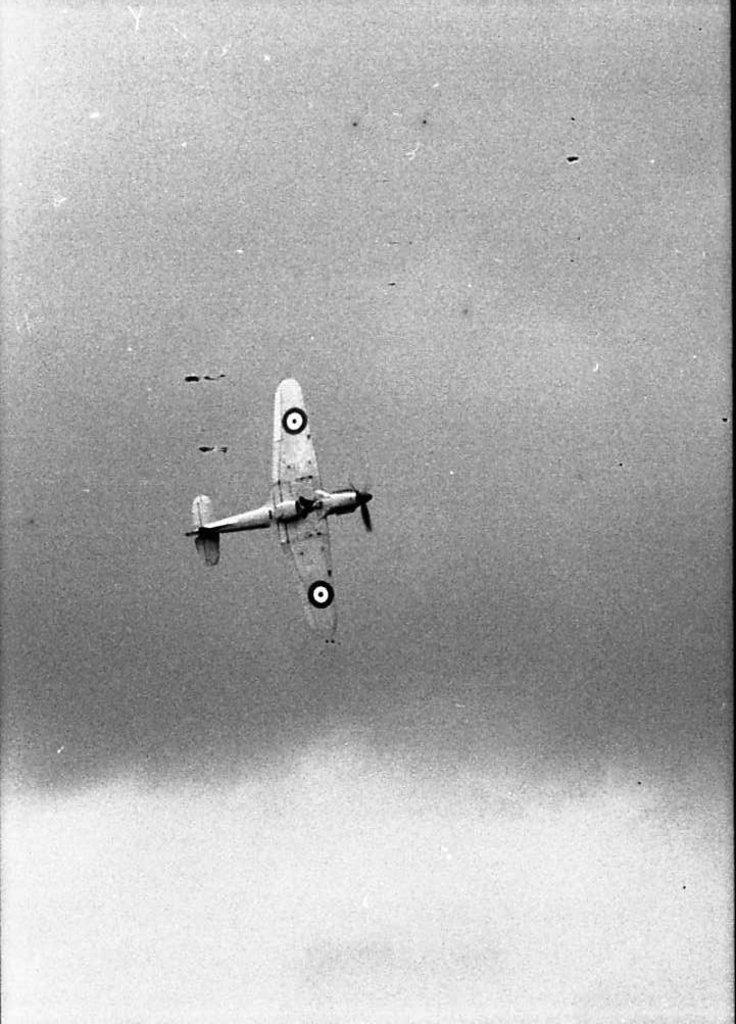What is the color scheme of the image? The picture is in black and white. What is the main subject of the image? There is a plane in the center of the image. What type of banana is hanging from the plane in the image? There is no banana present in the image, and therefore no such activity can be observed. 